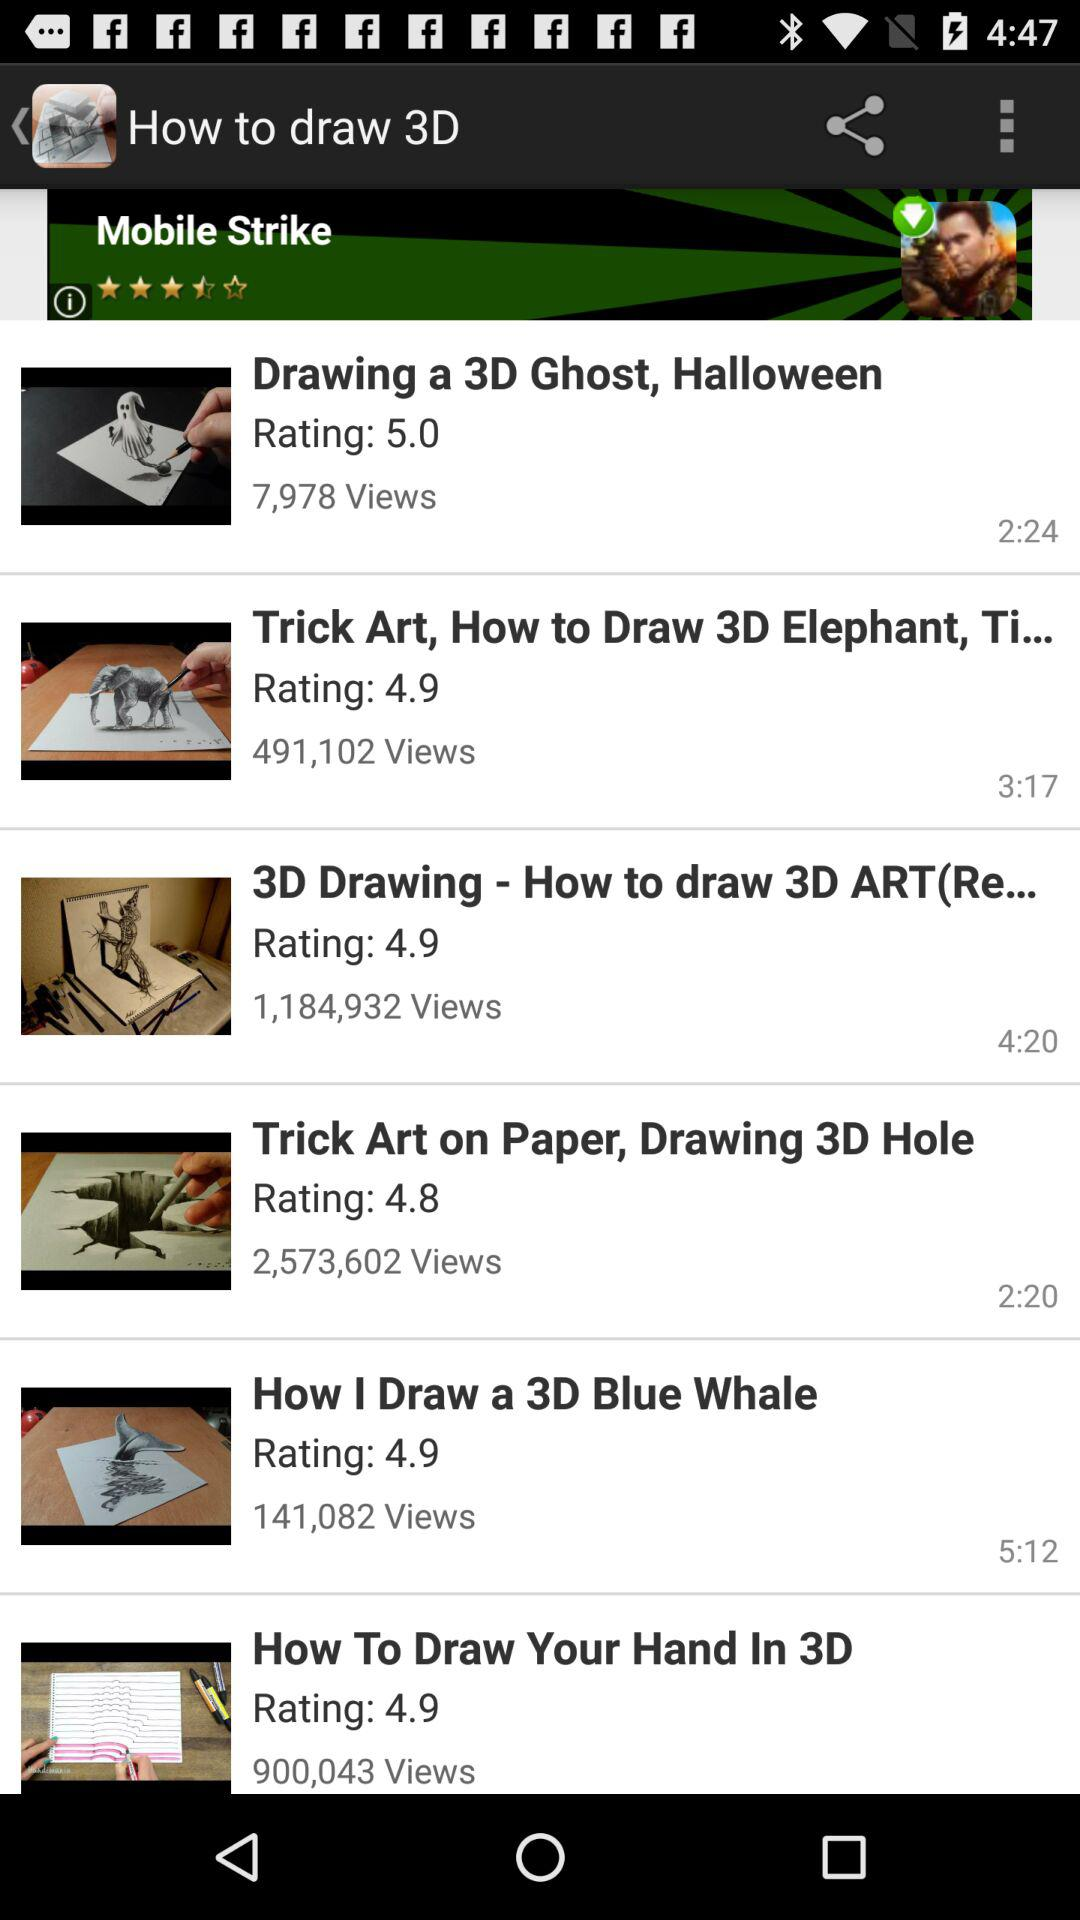What 3D drawing has a 4.8 rating? The 3D drawing that has a 4.8 rating is "Trick Art on Paper, Drawing 3D Hole". 